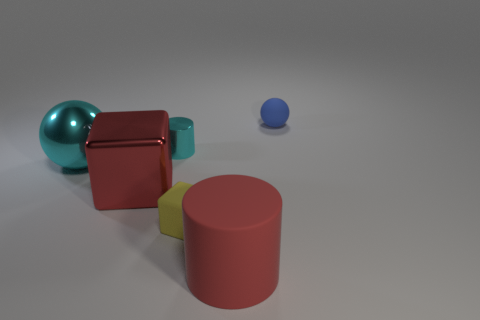What is the material of the large object that is the same shape as the small cyan metallic thing?
Your response must be concise. Rubber. How many cylinders are the same size as the blue rubber thing?
Provide a short and direct response. 1. How many small blue rubber objects are there?
Keep it short and to the point. 1. Do the cyan cylinder and the big red object behind the big rubber cylinder have the same material?
Your answer should be very brief. Yes. How many yellow objects are either cylinders or tiny rubber spheres?
Your response must be concise. 0. What is the size of the block that is made of the same material as the small sphere?
Make the answer very short. Small. How many cyan things have the same shape as the blue thing?
Your response must be concise. 1. Are there more small matte blocks that are to the right of the cyan metallic ball than tiny yellow things to the right of the small shiny object?
Offer a very short reply. No. Is the color of the rubber cylinder the same as the matte object behind the cyan ball?
Provide a succinct answer. No. There is a red cube that is the same size as the red rubber cylinder; what material is it?
Offer a terse response. Metal. 